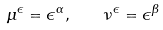Convert formula to latex. <formula><loc_0><loc_0><loc_500><loc_500>\mu ^ { \epsilon } = \epsilon ^ { \alpha } , \quad \nu ^ { \epsilon } = \epsilon ^ { \beta }</formula> 